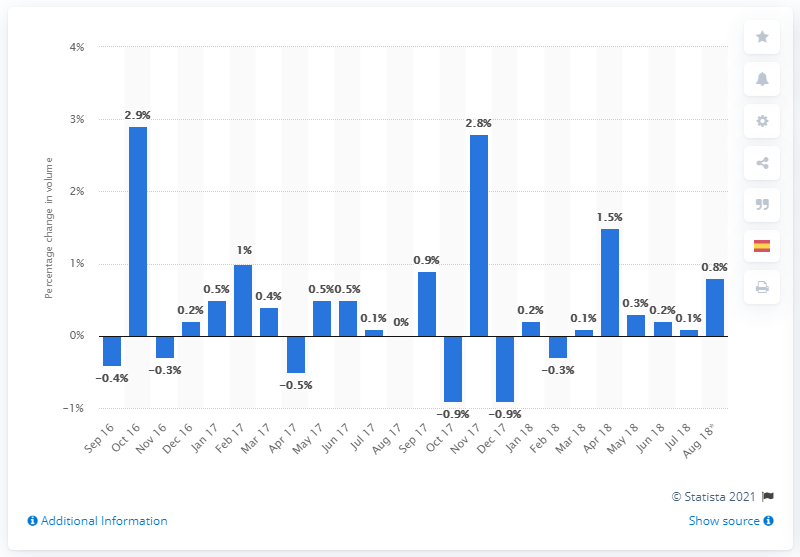Point out several critical features in this image. In August 2018, non-food retail sales volume increased by 0.8%. 